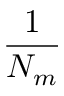Convert formula to latex. <formula><loc_0><loc_0><loc_500><loc_500>\frac { 1 } { N _ { m } }</formula> 